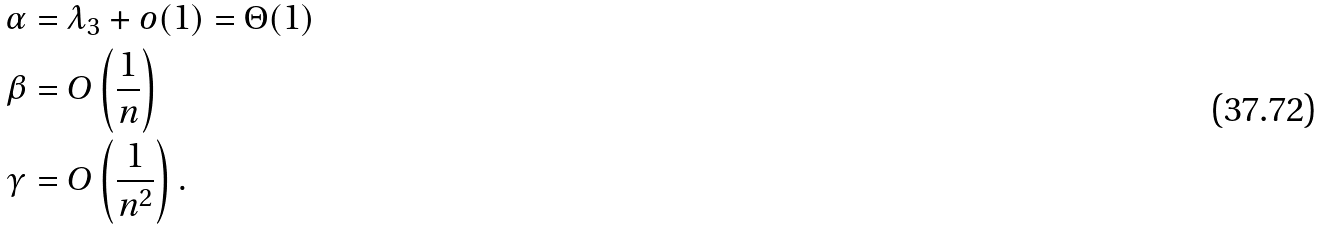<formula> <loc_0><loc_0><loc_500><loc_500>\alpha & = \lambda _ { 3 } + o ( 1 ) = \Theta ( 1 ) \\ \beta & = O \left ( \frac { 1 } { n } \right ) \\ \gamma & = O \left ( \frac { 1 } { n ^ { 2 } } \right ) .</formula> 